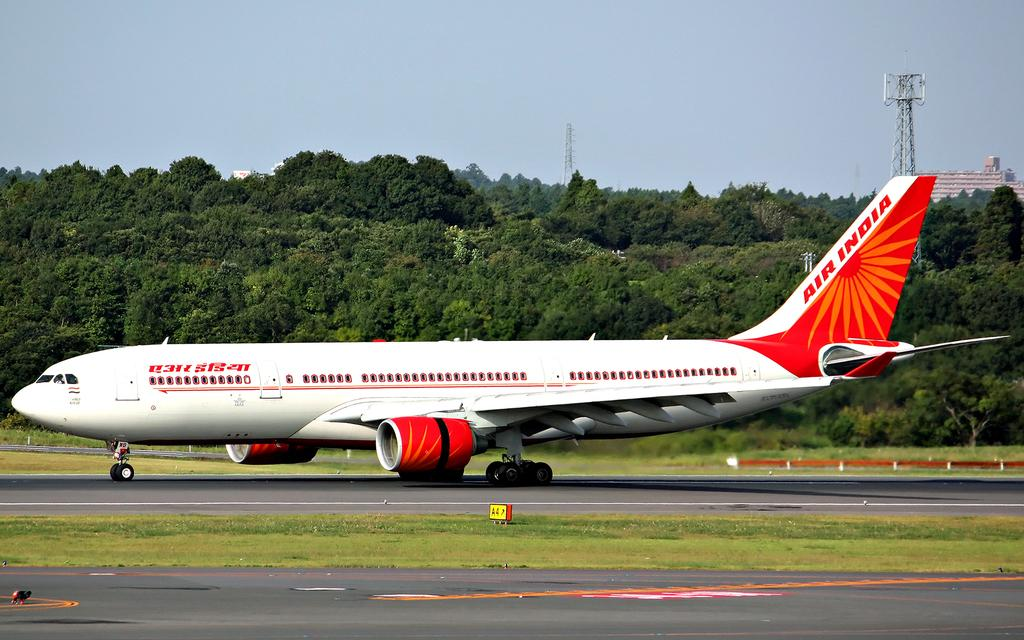What is the unusual object on the road in the image? There is an airplane on the road in the image. What type of vegetation can be seen in the image? There is grass visible in the image, and there are also trees. What structures are present in the image? There are towers and at least one building in the image. Can you describe the unspecified objects in the image? Unfortunately, the facts provided do not specify the nature of the unspecified objects in the image. What can be seen in the background of the image? The sky is visible in the background of the image. What type of jelly is being used to hold the head of the parcel in the image? There is no jelly, head, or parcel present in the image. 